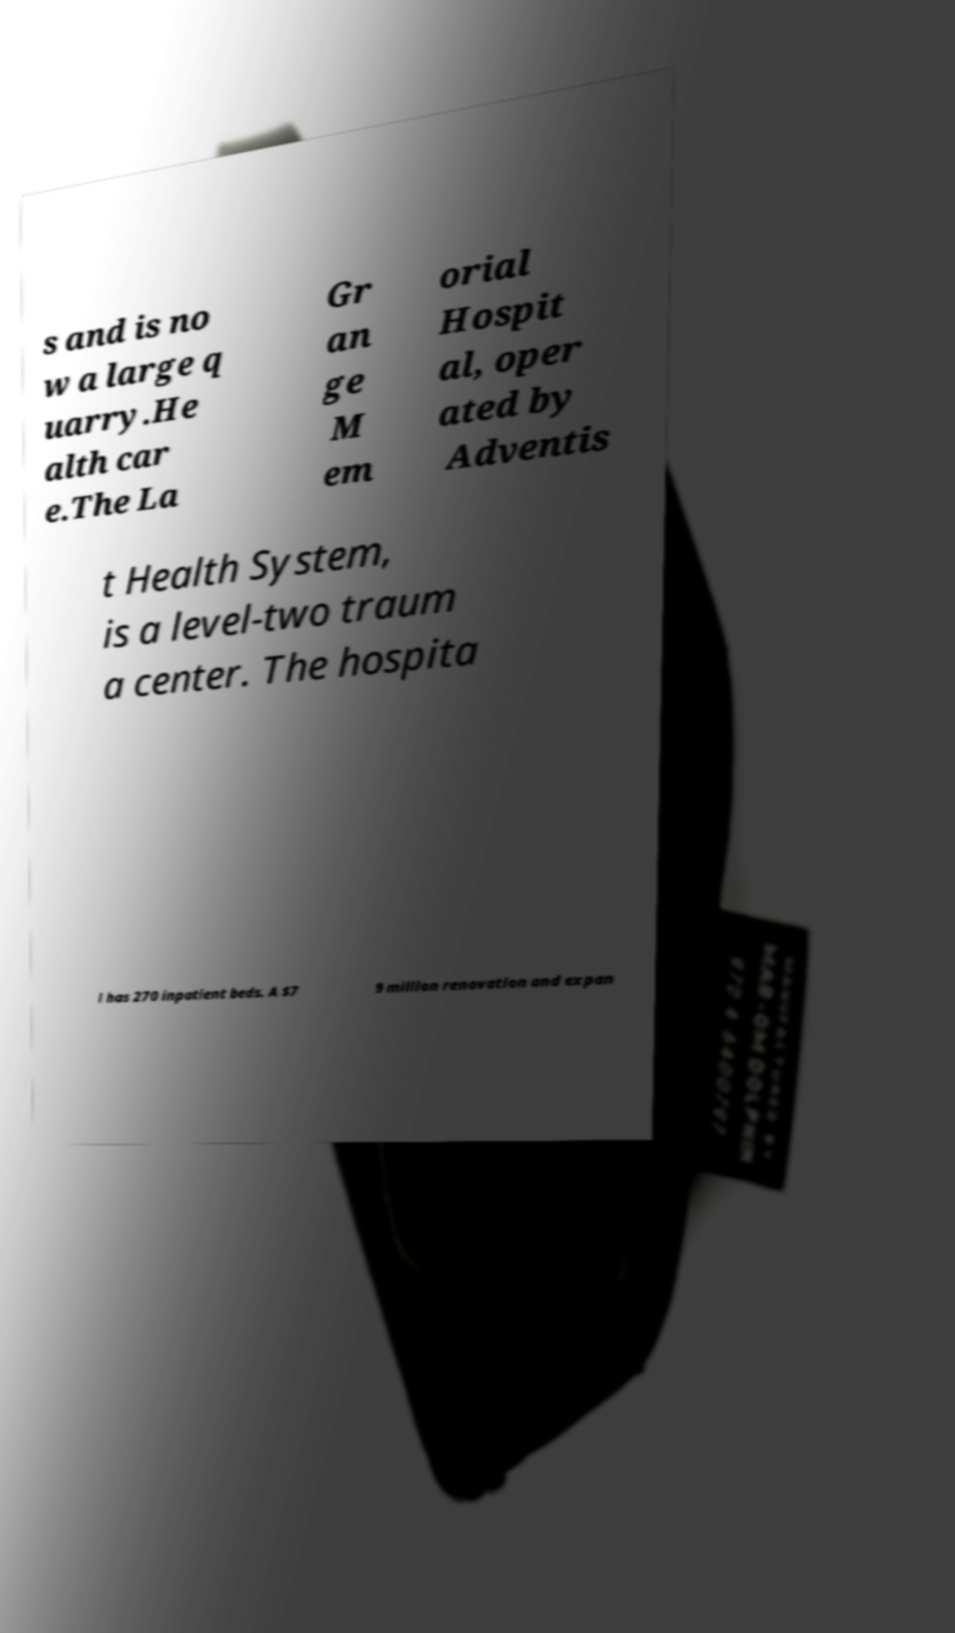For documentation purposes, I need the text within this image transcribed. Could you provide that? s and is no w a large q uarry.He alth car e.The La Gr an ge M em orial Hospit al, oper ated by Adventis t Health System, is a level-two traum a center. The hospita l has 270 inpatient beds. A $7 9 million renovation and expan 